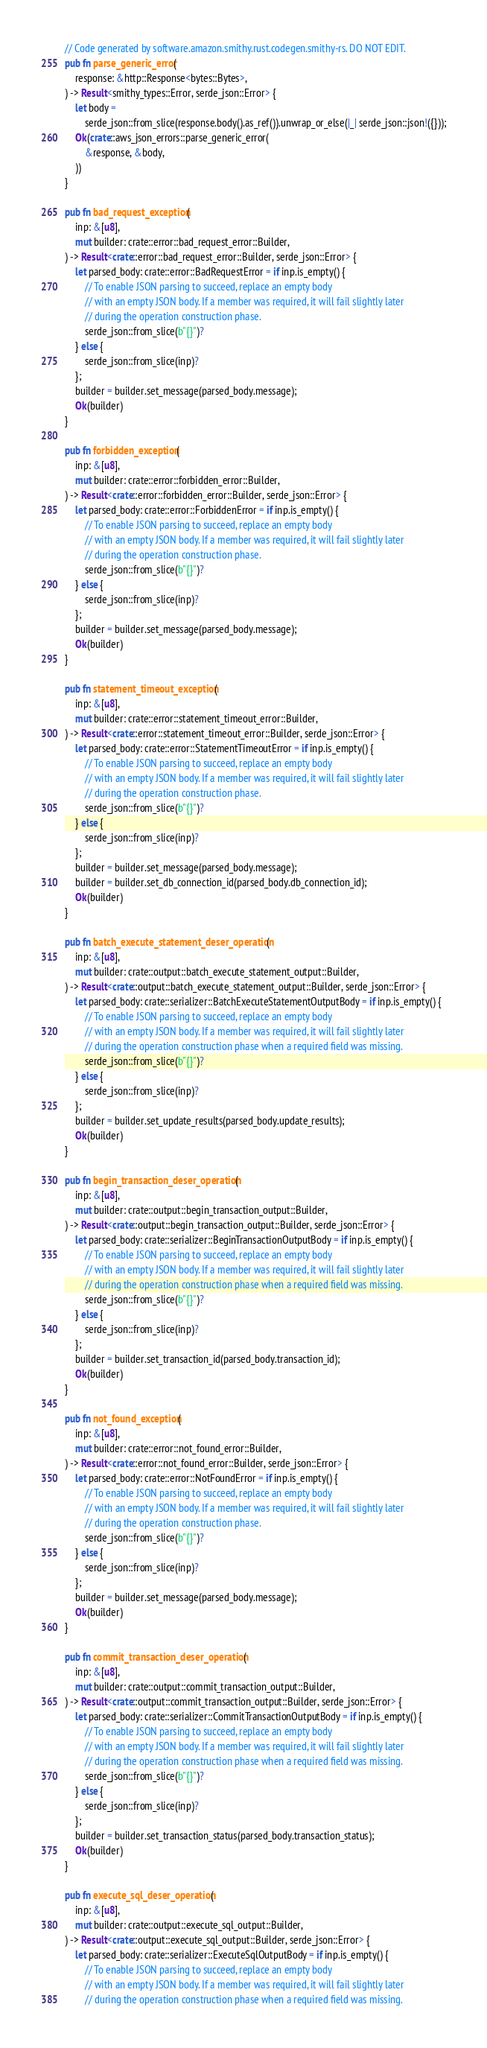Convert code to text. <code><loc_0><loc_0><loc_500><loc_500><_Rust_>// Code generated by software.amazon.smithy.rust.codegen.smithy-rs. DO NOT EDIT.
pub fn parse_generic_error(
    response: &http::Response<bytes::Bytes>,
) -> Result<smithy_types::Error, serde_json::Error> {
    let body =
        serde_json::from_slice(response.body().as_ref()).unwrap_or_else(|_| serde_json::json!({}));
    Ok(crate::aws_json_errors::parse_generic_error(
        &response, &body,
    ))
}

pub fn bad_request_exception(
    inp: &[u8],
    mut builder: crate::error::bad_request_error::Builder,
) -> Result<crate::error::bad_request_error::Builder, serde_json::Error> {
    let parsed_body: crate::error::BadRequestError = if inp.is_empty() {
        // To enable JSON parsing to succeed, replace an empty body
        // with an empty JSON body. If a member was required, it will fail slightly later
        // during the operation construction phase.
        serde_json::from_slice(b"{}")?
    } else {
        serde_json::from_slice(inp)?
    };
    builder = builder.set_message(parsed_body.message);
    Ok(builder)
}

pub fn forbidden_exception(
    inp: &[u8],
    mut builder: crate::error::forbidden_error::Builder,
) -> Result<crate::error::forbidden_error::Builder, serde_json::Error> {
    let parsed_body: crate::error::ForbiddenError = if inp.is_empty() {
        // To enable JSON parsing to succeed, replace an empty body
        // with an empty JSON body. If a member was required, it will fail slightly later
        // during the operation construction phase.
        serde_json::from_slice(b"{}")?
    } else {
        serde_json::from_slice(inp)?
    };
    builder = builder.set_message(parsed_body.message);
    Ok(builder)
}

pub fn statement_timeout_exception(
    inp: &[u8],
    mut builder: crate::error::statement_timeout_error::Builder,
) -> Result<crate::error::statement_timeout_error::Builder, serde_json::Error> {
    let parsed_body: crate::error::StatementTimeoutError = if inp.is_empty() {
        // To enable JSON parsing to succeed, replace an empty body
        // with an empty JSON body. If a member was required, it will fail slightly later
        // during the operation construction phase.
        serde_json::from_slice(b"{}")?
    } else {
        serde_json::from_slice(inp)?
    };
    builder = builder.set_message(parsed_body.message);
    builder = builder.set_db_connection_id(parsed_body.db_connection_id);
    Ok(builder)
}

pub fn batch_execute_statement_deser_operation(
    inp: &[u8],
    mut builder: crate::output::batch_execute_statement_output::Builder,
) -> Result<crate::output::batch_execute_statement_output::Builder, serde_json::Error> {
    let parsed_body: crate::serializer::BatchExecuteStatementOutputBody = if inp.is_empty() {
        // To enable JSON parsing to succeed, replace an empty body
        // with an empty JSON body. If a member was required, it will fail slightly later
        // during the operation construction phase when a required field was missing.
        serde_json::from_slice(b"{}")?
    } else {
        serde_json::from_slice(inp)?
    };
    builder = builder.set_update_results(parsed_body.update_results);
    Ok(builder)
}

pub fn begin_transaction_deser_operation(
    inp: &[u8],
    mut builder: crate::output::begin_transaction_output::Builder,
) -> Result<crate::output::begin_transaction_output::Builder, serde_json::Error> {
    let parsed_body: crate::serializer::BeginTransactionOutputBody = if inp.is_empty() {
        // To enable JSON parsing to succeed, replace an empty body
        // with an empty JSON body. If a member was required, it will fail slightly later
        // during the operation construction phase when a required field was missing.
        serde_json::from_slice(b"{}")?
    } else {
        serde_json::from_slice(inp)?
    };
    builder = builder.set_transaction_id(parsed_body.transaction_id);
    Ok(builder)
}

pub fn not_found_exception(
    inp: &[u8],
    mut builder: crate::error::not_found_error::Builder,
) -> Result<crate::error::not_found_error::Builder, serde_json::Error> {
    let parsed_body: crate::error::NotFoundError = if inp.is_empty() {
        // To enable JSON parsing to succeed, replace an empty body
        // with an empty JSON body. If a member was required, it will fail slightly later
        // during the operation construction phase.
        serde_json::from_slice(b"{}")?
    } else {
        serde_json::from_slice(inp)?
    };
    builder = builder.set_message(parsed_body.message);
    Ok(builder)
}

pub fn commit_transaction_deser_operation(
    inp: &[u8],
    mut builder: crate::output::commit_transaction_output::Builder,
) -> Result<crate::output::commit_transaction_output::Builder, serde_json::Error> {
    let parsed_body: crate::serializer::CommitTransactionOutputBody = if inp.is_empty() {
        // To enable JSON parsing to succeed, replace an empty body
        // with an empty JSON body. If a member was required, it will fail slightly later
        // during the operation construction phase when a required field was missing.
        serde_json::from_slice(b"{}")?
    } else {
        serde_json::from_slice(inp)?
    };
    builder = builder.set_transaction_status(parsed_body.transaction_status);
    Ok(builder)
}

pub fn execute_sql_deser_operation(
    inp: &[u8],
    mut builder: crate::output::execute_sql_output::Builder,
) -> Result<crate::output::execute_sql_output::Builder, serde_json::Error> {
    let parsed_body: crate::serializer::ExecuteSqlOutputBody = if inp.is_empty() {
        // To enable JSON parsing to succeed, replace an empty body
        // with an empty JSON body. If a member was required, it will fail slightly later
        // during the operation construction phase when a required field was missing.</code> 